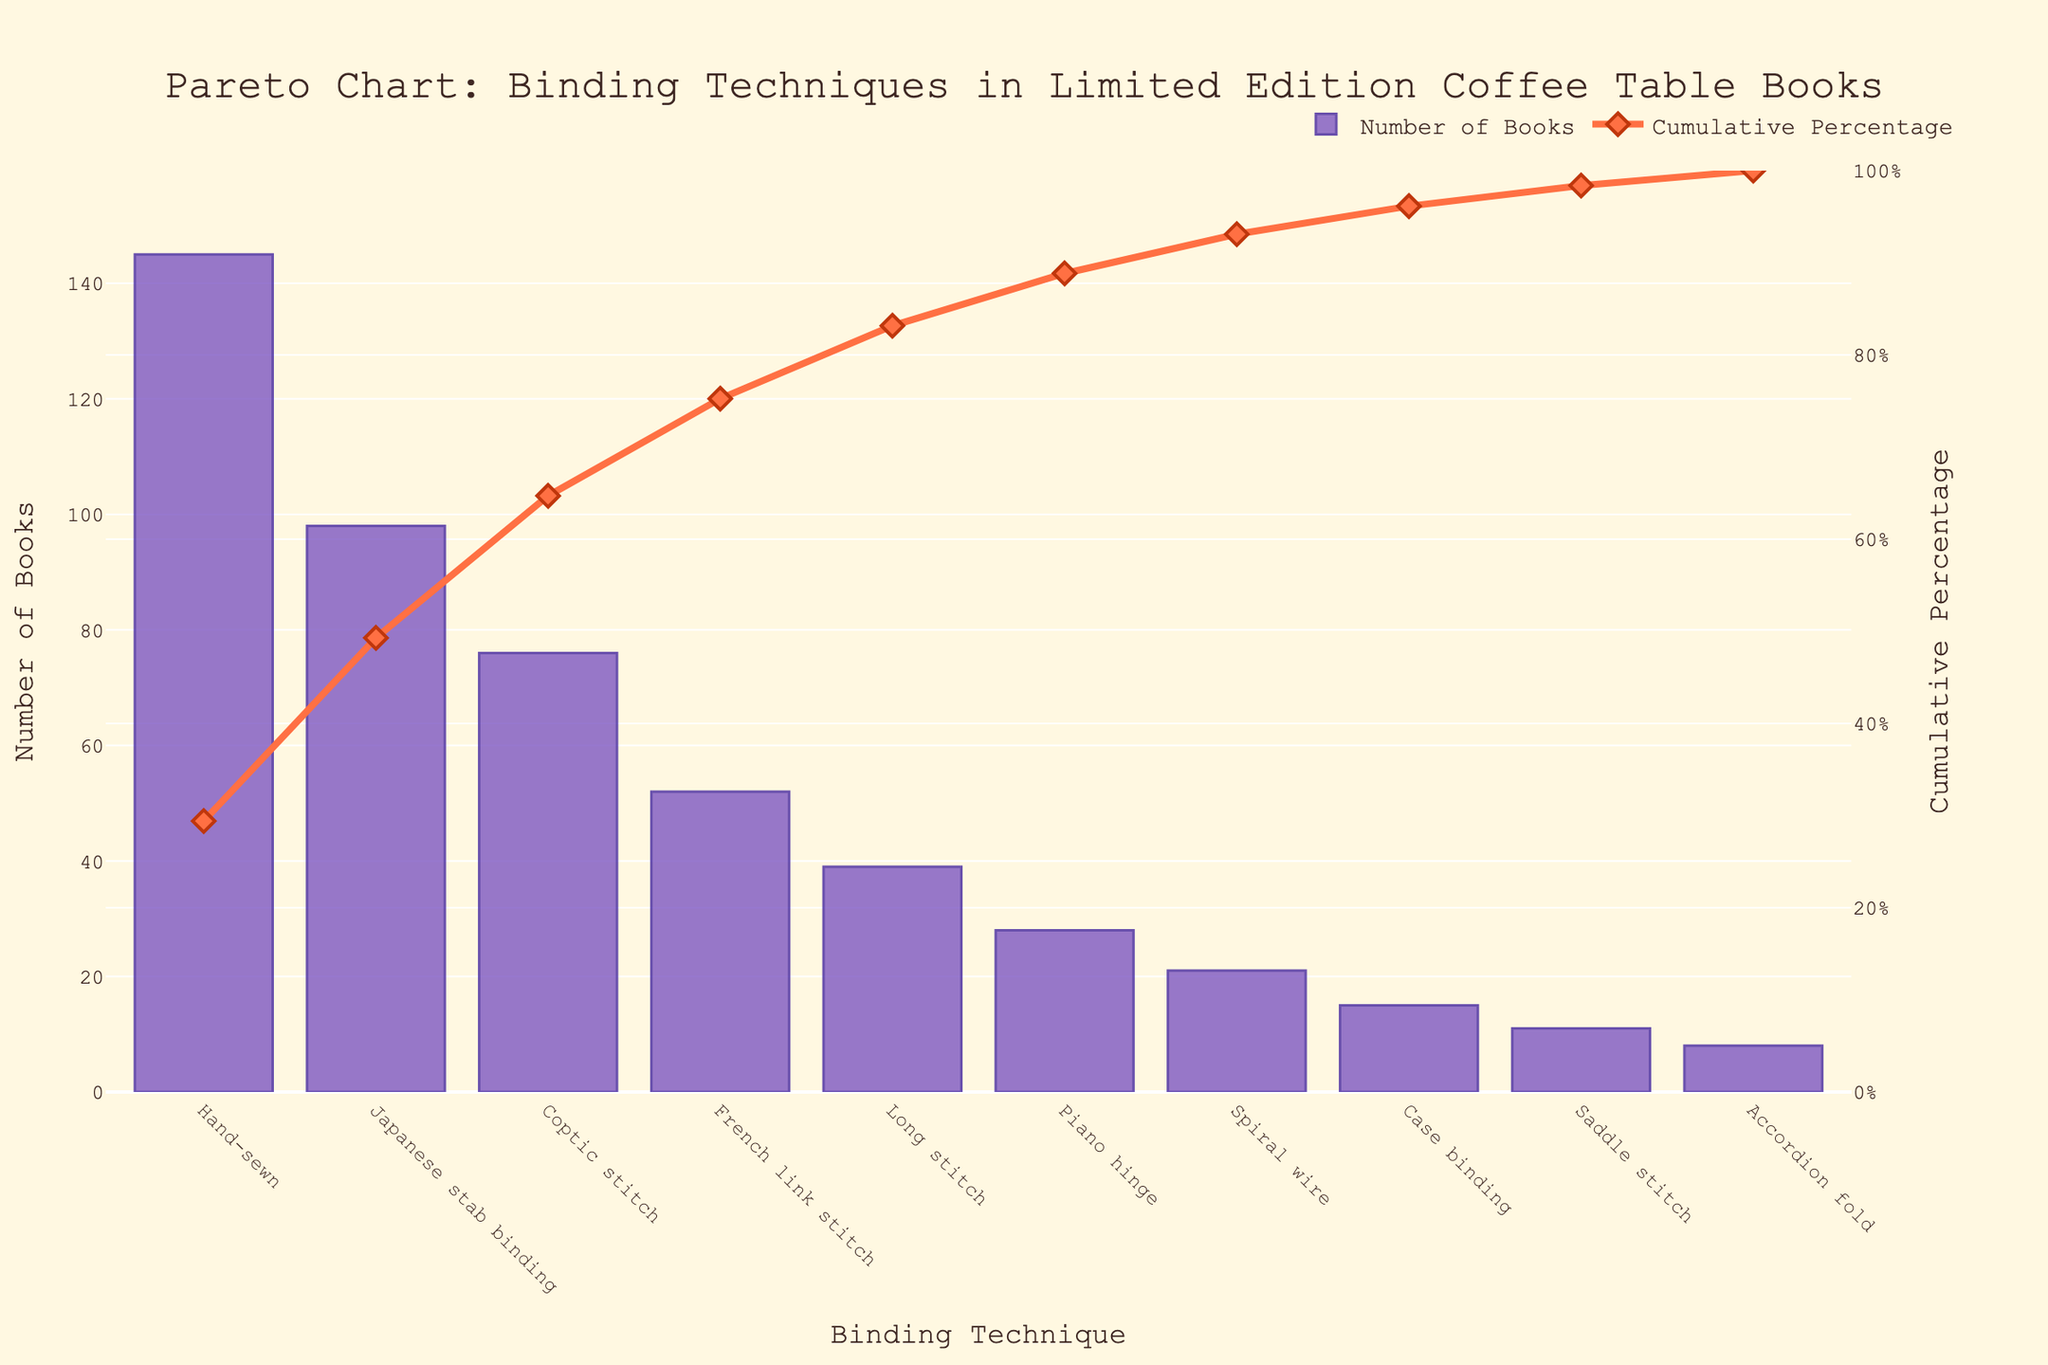What's the title of the chart? The title is displayed at the top center of the chart, and it helps in understanding the context of the data presented. The title is "Pareto Chart: Binding Techniques in Limited Edition Coffee Table Books."
Answer: Pareto Chart: Binding Techniques in Limited Edition Coffee Table Books How many binding techniques are displayed? By counting the number of unique binding techniques listed on the x-axis, we can determine the total number. There are 10 binding techniques shown.
Answer: 10 Which binding technique has the highest number of books? By looking at the height of the bars, the highest bar represents the binding technique with the most books. "Hand-sewn" has the tallest bar.
Answer: Hand-sewn What's the cumulative percentage of the top two techniques? The cumulative percentage can be found by adding the percentages for the top two techniques from the line chart. "Hand-sewn" has a cumulative percentage of approximately 29%, and "Japanese stab binding" adds up to approximately 49%. The combined cumulative percentage is 29% + 20% = 49%.
Answer: 49% Which technique contributes to reaching the 80% cumulative percentage mark on the chart? By following the cumulative percentage line on the secondary y-axis, we see that the techniques "Hand-sewn," "Japanese stab binding," "Coptic stitch," "French link stitch," "Long stitch," and "Piano hinge" together bring the cumulative percentage to roughly 80%.
Answer: Piano hinge How many books are bound using "Long stitch"? The bar corresponding to "Long stitch" on the x-axis shows its height, representing the number of books. "Long stitch" has 39 books.
Answer: 39 Are there more books bound with "Saddle stitch" or "Accordion fold"? By comparing the heights of the bars for "Saddle stitch" and "Accordion fold," we find that "Saddle stitch" has a higher bar with 11 books, while "Accordion fold" has a shorter bar with 8 books.
Answer: Saddle stitch What is the difference in the number of books between "Hand-sewn" and "Case binding"? The heights of the bars for "Hand-sewn" and "Case binding" represent the number of books. "Hand-sewn" has 145 books, and "Case binding" has 15 books. The difference is 145 - 15 = 130 books.
Answer: 130 What is the cumulative percentage after the third technique in descending order? The cumulative percentages for the top three techniques "Hand-sewn," "Japanese stab binding," and "Coptic stitch" can be added together. They are approximately 29%, 20%, and 13% respectively. The sum is 29% + 20% + 13% = 62%.
Answer: 62% Is there any binding technique that contributes less than 5% individually to the total number of books? "Saddle stitch" contributes approximately 2.2% (11/520 * 100), "Accordion fold" contributes around 1.5% (8/520 * 100), both are individually less than 5%.
Answer: Yes 